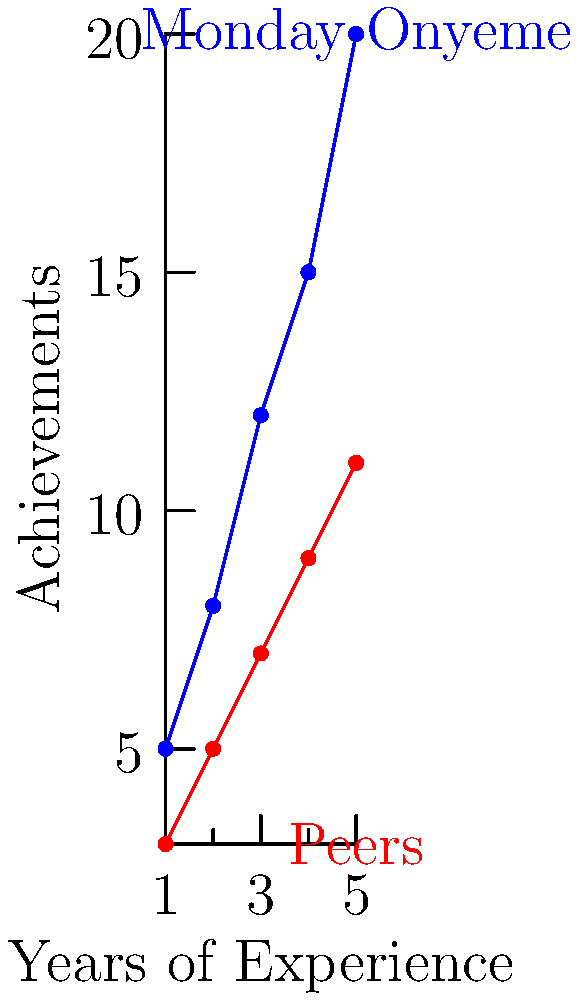Based on the scatter plot comparing Monday Onyeme's achievements with those of his peers over years of experience, what is the difference in achievements between Monday and his peers after 5 years of experience? To find the difference in achievements between Monday Onyeme and his peers after 5 years of experience, we need to:

1. Locate the data points for 5 years of experience on the x-axis.
2. Find the corresponding y-values (achievements) for both Monday Onyeme (blue) and his peers (red).
3. Calculate the difference between these two y-values.

Step 1: At x = 5 (5 years of experience)
Step 2: 
- Monday Onyeme's achievement (blue): y = 20
- Peers' achievement (red): y = 11
Step 3: Difference = Monday's achievement - Peers' achievement
        $$20 - 11 = 9$$

Therefore, the difference in achievements between Monday Onyeme and his peers after 5 years of experience is 9.
Answer: 9 